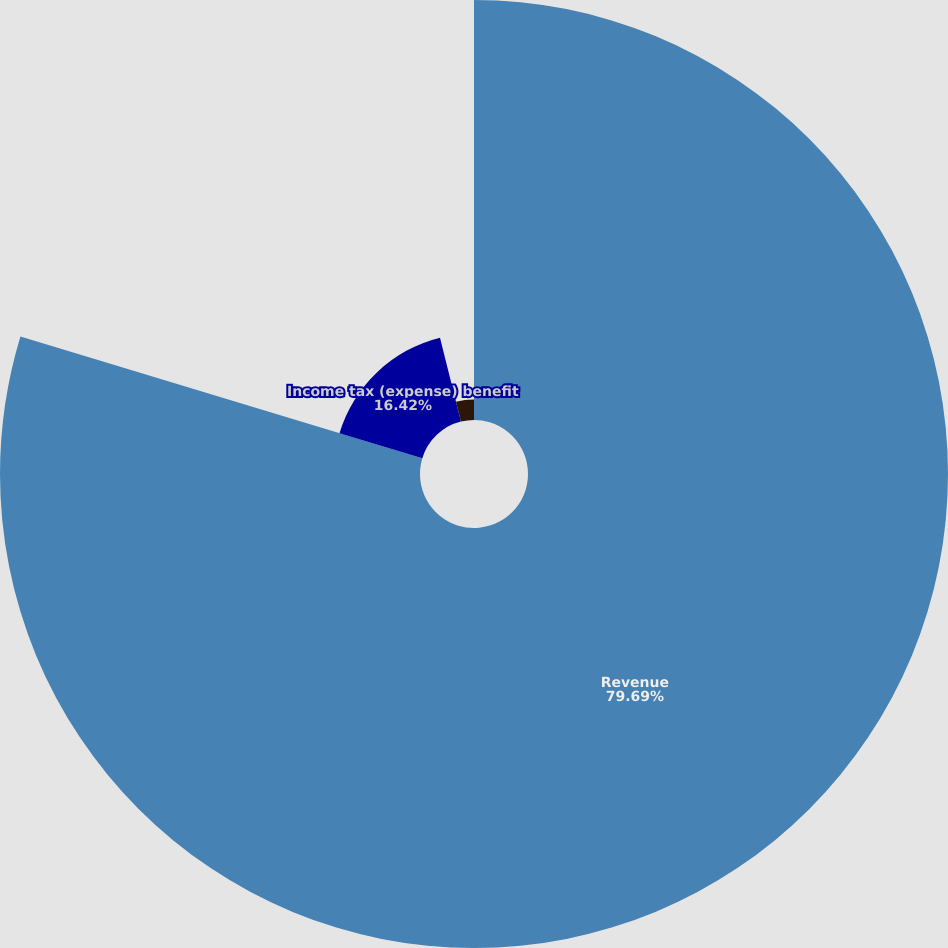Convert chart. <chart><loc_0><loc_0><loc_500><loc_500><pie_chart><fcel>Revenue<fcel>Income tax (expense) benefit<fcel>Gain (loss) on disposal of<nl><fcel>79.68%<fcel>16.42%<fcel>3.89%<nl></chart> 